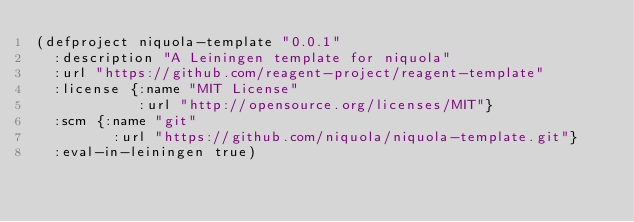Convert code to text. <code><loc_0><loc_0><loc_500><loc_500><_Clojure_>(defproject niquola-template "0.0.1"
  :description "A Leiningen template for niquola"
  :url "https://github.com/reagent-project/reagent-template"
  :license {:name "MIT License"
            :url "http://opensource.org/licenses/MIT"}
  :scm {:name "git"
         :url "https://github.com/niquola/niquola-template.git"}
  :eval-in-leiningen true)
</code> 